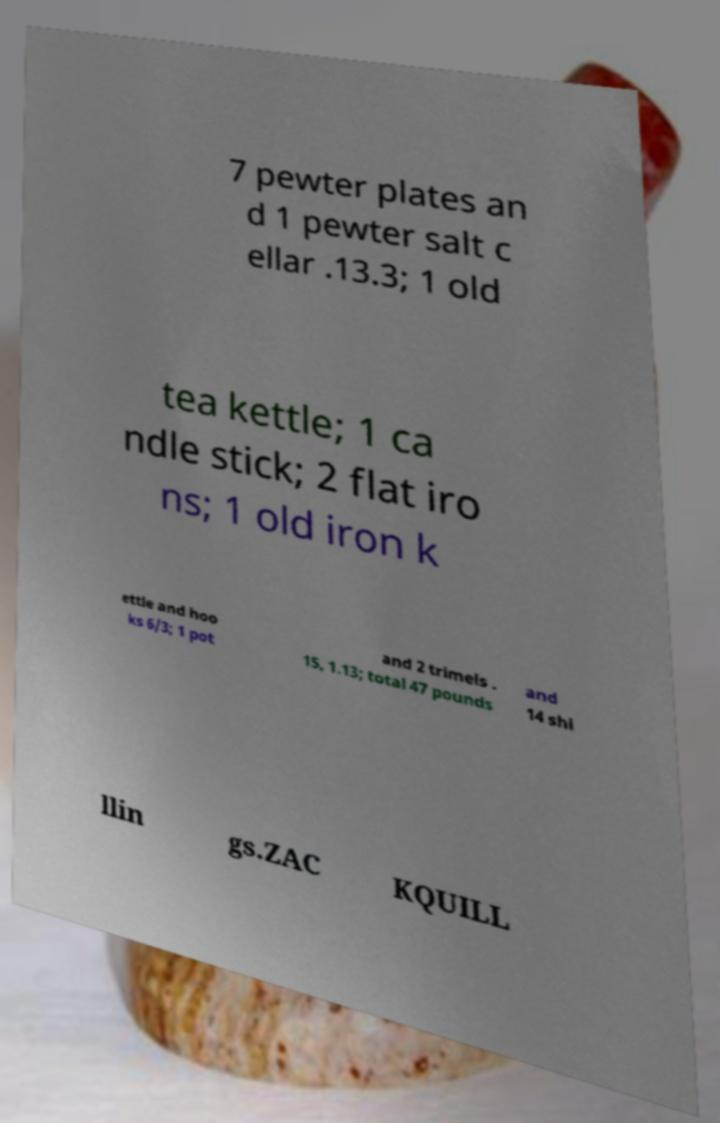For documentation purposes, I need the text within this image transcribed. Could you provide that? 7 pewter plates an d 1 pewter salt c ellar .13.3; 1 old tea kettle; 1 ca ndle stick; 2 flat iro ns; 1 old iron k ettle and hoo ks 6/3; 1 pot and 2 trimels . 15, 1.13; total 47 pounds and 14 shi llin gs.ZAC KQUILL 